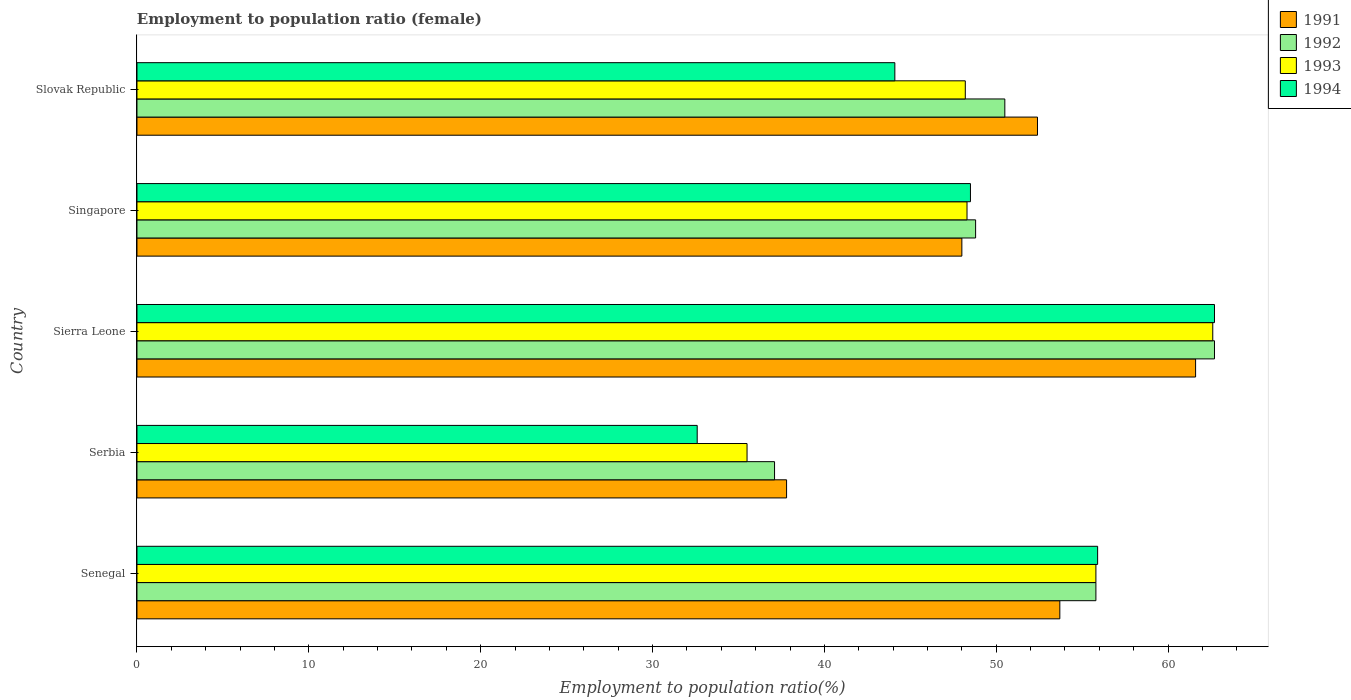How many different coloured bars are there?
Offer a terse response. 4. How many groups of bars are there?
Offer a very short reply. 5. Are the number of bars per tick equal to the number of legend labels?
Provide a succinct answer. Yes. How many bars are there on the 3rd tick from the top?
Give a very brief answer. 4. What is the label of the 1st group of bars from the top?
Keep it short and to the point. Slovak Republic. What is the employment to population ratio in 1993 in Senegal?
Ensure brevity in your answer.  55.8. Across all countries, what is the maximum employment to population ratio in 1994?
Your answer should be compact. 62.7. Across all countries, what is the minimum employment to population ratio in 1994?
Provide a succinct answer. 32.6. In which country was the employment to population ratio in 1994 maximum?
Offer a very short reply. Sierra Leone. In which country was the employment to population ratio in 1991 minimum?
Provide a short and direct response. Serbia. What is the total employment to population ratio in 1991 in the graph?
Offer a terse response. 253.5. What is the difference between the employment to population ratio in 1991 in Serbia and that in Slovak Republic?
Provide a succinct answer. -14.6. What is the difference between the employment to population ratio in 1993 in Serbia and the employment to population ratio in 1991 in Singapore?
Give a very brief answer. -12.5. What is the average employment to population ratio in 1991 per country?
Your answer should be very brief. 50.7. What is the difference between the employment to population ratio in 1994 and employment to population ratio in 1991 in Serbia?
Provide a succinct answer. -5.2. In how many countries, is the employment to population ratio in 1992 greater than 60 %?
Offer a very short reply. 1. What is the ratio of the employment to population ratio in 1993 in Senegal to that in Serbia?
Give a very brief answer. 1.57. Is the difference between the employment to population ratio in 1994 in Senegal and Slovak Republic greater than the difference between the employment to population ratio in 1991 in Senegal and Slovak Republic?
Your answer should be compact. Yes. What is the difference between the highest and the second highest employment to population ratio in 1991?
Give a very brief answer. 7.9. What is the difference between the highest and the lowest employment to population ratio in 1993?
Your answer should be very brief. 27.1. What does the 4th bar from the bottom in Senegal represents?
Your answer should be compact. 1994. Is it the case that in every country, the sum of the employment to population ratio in 1993 and employment to population ratio in 1992 is greater than the employment to population ratio in 1994?
Offer a terse response. Yes. How many bars are there?
Your answer should be compact. 20. What is the difference between two consecutive major ticks on the X-axis?
Give a very brief answer. 10. How many legend labels are there?
Ensure brevity in your answer.  4. How are the legend labels stacked?
Keep it short and to the point. Vertical. What is the title of the graph?
Give a very brief answer. Employment to population ratio (female). What is the Employment to population ratio(%) in 1991 in Senegal?
Provide a succinct answer. 53.7. What is the Employment to population ratio(%) of 1992 in Senegal?
Give a very brief answer. 55.8. What is the Employment to population ratio(%) in 1993 in Senegal?
Make the answer very short. 55.8. What is the Employment to population ratio(%) of 1994 in Senegal?
Offer a terse response. 55.9. What is the Employment to population ratio(%) of 1991 in Serbia?
Offer a terse response. 37.8. What is the Employment to population ratio(%) of 1992 in Serbia?
Provide a succinct answer. 37.1. What is the Employment to population ratio(%) in 1993 in Serbia?
Ensure brevity in your answer.  35.5. What is the Employment to population ratio(%) of 1994 in Serbia?
Your answer should be very brief. 32.6. What is the Employment to population ratio(%) in 1991 in Sierra Leone?
Provide a succinct answer. 61.6. What is the Employment to population ratio(%) in 1992 in Sierra Leone?
Provide a succinct answer. 62.7. What is the Employment to population ratio(%) in 1993 in Sierra Leone?
Provide a short and direct response. 62.6. What is the Employment to population ratio(%) of 1994 in Sierra Leone?
Your response must be concise. 62.7. What is the Employment to population ratio(%) of 1992 in Singapore?
Offer a terse response. 48.8. What is the Employment to population ratio(%) of 1993 in Singapore?
Your response must be concise. 48.3. What is the Employment to population ratio(%) of 1994 in Singapore?
Make the answer very short. 48.5. What is the Employment to population ratio(%) in 1991 in Slovak Republic?
Keep it short and to the point. 52.4. What is the Employment to population ratio(%) of 1992 in Slovak Republic?
Keep it short and to the point. 50.5. What is the Employment to population ratio(%) of 1993 in Slovak Republic?
Your answer should be compact. 48.2. What is the Employment to population ratio(%) in 1994 in Slovak Republic?
Give a very brief answer. 44.1. Across all countries, what is the maximum Employment to population ratio(%) in 1991?
Your answer should be compact. 61.6. Across all countries, what is the maximum Employment to population ratio(%) of 1992?
Offer a terse response. 62.7. Across all countries, what is the maximum Employment to population ratio(%) in 1993?
Give a very brief answer. 62.6. Across all countries, what is the maximum Employment to population ratio(%) in 1994?
Make the answer very short. 62.7. Across all countries, what is the minimum Employment to population ratio(%) of 1991?
Keep it short and to the point. 37.8. Across all countries, what is the minimum Employment to population ratio(%) in 1992?
Offer a terse response. 37.1. Across all countries, what is the minimum Employment to population ratio(%) of 1993?
Your response must be concise. 35.5. Across all countries, what is the minimum Employment to population ratio(%) of 1994?
Your response must be concise. 32.6. What is the total Employment to population ratio(%) of 1991 in the graph?
Ensure brevity in your answer.  253.5. What is the total Employment to population ratio(%) of 1992 in the graph?
Your response must be concise. 254.9. What is the total Employment to population ratio(%) of 1993 in the graph?
Give a very brief answer. 250.4. What is the total Employment to population ratio(%) of 1994 in the graph?
Offer a terse response. 243.8. What is the difference between the Employment to population ratio(%) in 1991 in Senegal and that in Serbia?
Provide a succinct answer. 15.9. What is the difference between the Employment to population ratio(%) in 1992 in Senegal and that in Serbia?
Make the answer very short. 18.7. What is the difference between the Employment to population ratio(%) in 1993 in Senegal and that in Serbia?
Make the answer very short. 20.3. What is the difference between the Employment to population ratio(%) in 1994 in Senegal and that in Serbia?
Provide a succinct answer. 23.3. What is the difference between the Employment to population ratio(%) of 1991 in Senegal and that in Sierra Leone?
Keep it short and to the point. -7.9. What is the difference between the Employment to population ratio(%) in 1992 in Senegal and that in Sierra Leone?
Make the answer very short. -6.9. What is the difference between the Employment to population ratio(%) in 1993 in Senegal and that in Sierra Leone?
Provide a succinct answer. -6.8. What is the difference between the Employment to population ratio(%) in 1992 in Senegal and that in Singapore?
Provide a succinct answer. 7. What is the difference between the Employment to population ratio(%) of 1991 in Senegal and that in Slovak Republic?
Offer a very short reply. 1.3. What is the difference between the Employment to population ratio(%) in 1992 in Senegal and that in Slovak Republic?
Offer a very short reply. 5.3. What is the difference between the Employment to population ratio(%) of 1991 in Serbia and that in Sierra Leone?
Keep it short and to the point. -23.8. What is the difference between the Employment to population ratio(%) of 1992 in Serbia and that in Sierra Leone?
Keep it short and to the point. -25.6. What is the difference between the Employment to population ratio(%) in 1993 in Serbia and that in Sierra Leone?
Offer a terse response. -27.1. What is the difference between the Employment to population ratio(%) of 1994 in Serbia and that in Sierra Leone?
Offer a very short reply. -30.1. What is the difference between the Employment to population ratio(%) in 1994 in Serbia and that in Singapore?
Keep it short and to the point. -15.9. What is the difference between the Employment to population ratio(%) in 1991 in Serbia and that in Slovak Republic?
Your answer should be compact. -14.6. What is the difference between the Employment to population ratio(%) in 1992 in Serbia and that in Slovak Republic?
Your answer should be very brief. -13.4. What is the difference between the Employment to population ratio(%) of 1991 in Sierra Leone and that in Slovak Republic?
Give a very brief answer. 9.2. What is the difference between the Employment to population ratio(%) of 1993 in Sierra Leone and that in Slovak Republic?
Ensure brevity in your answer.  14.4. What is the difference between the Employment to population ratio(%) in 1991 in Singapore and that in Slovak Republic?
Ensure brevity in your answer.  -4.4. What is the difference between the Employment to population ratio(%) in 1992 in Singapore and that in Slovak Republic?
Ensure brevity in your answer.  -1.7. What is the difference between the Employment to population ratio(%) in 1994 in Singapore and that in Slovak Republic?
Provide a succinct answer. 4.4. What is the difference between the Employment to population ratio(%) in 1991 in Senegal and the Employment to population ratio(%) in 1992 in Serbia?
Give a very brief answer. 16.6. What is the difference between the Employment to population ratio(%) of 1991 in Senegal and the Employment to population ratio(%) of 1994 in Serbia?
Your answer should be very brief. 21.1. What is the difference between the Employment to population ratio(%) of 1992 in Senegal and the Employment to population ratio(%) of 1993 in Serbia?
Ensure brevity in your answer.  20.3. What is the difference between the Employment to population ratio(%) in 1992 in Senegal and the Employment to population ratio(%) in 1994 in Serbia?
Keep it short and to the point. 23.2. What is the difference between the Employment to population ratio(%) of 1993 in Senegal and the Employment to population ratio(%) of 1994 in Serbia?
Provide a succinct answer. 23.2. What is the difference between the Employment to population ratio(%) of 1991 in Senegal and the Employment to population ratio(%) of 1992 in Sierra Leone?
Your response must be concise. -9. What is the difference between the Employment to population ratio(%) in 1991 in Senegal and the Employment to population ratio(%) in 1993 in Sierra Leone?
Make the answer very short. -8.9. What is the difference between the Employment to population ratio(%) of 1991 in Senegal and the Employment to population ratio(%) of 1994 in Sierra Leone?
Ensure brevity in your answer.  -9. What is the difference between the Employment to population ratio(%) of 1991 in Senegal and the Employment to population ratio(%) of 1993 in Singapore?
Your response must be concise. 5.4. What is the difference between the Employment to population ratio(%) in 1991 in Senegal and the Employment to population ratio(%) in 1994 in Singapore?
Keep it short and to the point. 5.2. What is the difference between the Employment to population ratio(%) in 1992 in Senegal and the Employment to population ratio(%) in 1993 in Singapore?
Offer a very short reply. 7.5. What is the difference between the Employment to population ratio(%) in 1993 in Senegal and the Employment to population ratio(%) in 1994 in Singapore?
Provide a succinct answer. 7.3. What is the difference between the Employment to population ratio(%) in 1991 in Senegal and the Employment to population ratio(%) in 1992 in Slovak Republic?
Keep it short and to the point. 3.2. What is the difference between the Employment to population ratio(%) of 1991 in Senegal and the Employment to population ratio(%) of 1994 in Slovak Republic?
Give a very brief answer. 9.6. What is the difference between the Employment to population ratio(%) of 1991 in Serbia and the Employment to population ratio(%) of 1992 in Sierra Leone?
Your response must be concise. -24.9. What is the difference between the Employment to population ratio(%) of 1991 in Serbia and the Employment to population ratio(%) of 1993 in Sierra Leone?
Provide a short and direct response. -24.8. What is the difference between the Employment to population ratio(%) of 1991 in Serbia and the Employment to population ratio(%) of 1994 in Sierra Leone?
Provide a short and direct response. -24.9. What is the difference between the Employment to population ratio(%) of 1992 in Serbia and the Employment to population ratio(%) of 1993 in Sierra Leone?
Offer a terse response. -25.5. What is the difference between the Employment to population ratio(%) in 1992 in Serbia and the Employment to population ratio(%) in 1994 in Sierra Leone?
Your response must be concise. -25.6. What is the difference between the Employment to population ratio(%) of 1993 in Serbia and the Employment to population ratio(%) of 1994 in Sierra Leone?
Your answer should be very brief. -27.2. What is the difference between the Employment to population ratio(%) in 1991 in Serbia and the Employment to population ratio(%) in 1993 in Singapore?
Your answer should be very brief. -10.5. What is the difference between the Employment to population ratio(%) in 1991 in Serbia and the Employment to population ratio(%) in 1994 in Singapore?
Your answer should be very brief. -10.7. What is the difference between the Employment to population ratio(%) of 1992 in Serbia and the Employment to population ratio(%) of 1993 in Singapore?
Give a very brief answer. -11.2. What is the difference between the Employment to population ratio(%) in 1991 in Serbia and the Employment to population ratio(%) in 1992 in Slovak Republic?
Offer a very short reply. -12.7. What is the difference between the Employment to population ratio(%) of 1992 in Serbia and the Employment to population ratio(%) of 1993 in Slovak Republic?
Offer a terse response. -11.1. What is the difference between the Employment to population ratio(%) of 1992 in Serbia and the Employment to population ratio(%) of 1994 in Slovak Republic?
Provide a succinct answer. -7. What is the difference between the Employment to population ratio(%) of 1991 in Sierra Leone and the Employment to population ratio(%) of 1993 in Singapore?
Keep it short and to the point. 13.3. What is the difference between the Employment to population ratio(%) in 1991 in Sierra Leone and the Employment to population ratio(%) in 1993 in Slovak Republic?
Your response must be concise. 13.4. What is the difference between the Employment to population ratio(%) in 1991 in Sierra Leone and the Employment to population ratio(%) in 1994 in Slovak Republic?
Provide a short and direct response. 17.5. What is the difference between the Employment to population ratio(%) in 1992 in Sierra Leone and the Employment to population ratio(%) in 1993 in Slovak Republic?
Offer a very short reply. 14.5. What is the difference between the Employment to population ratio(%) in 1991 in Singapore and the Employment to population ratio(%) in 1992 in Slovak Republic?
Make the answer very short. -2.5. What is the difference between the Employment to population ratio(%) of 1992 in Singapore and the Employment to population ratio(%) of 1993 in Slovak Republic?
Your response must be concise. 0.6. What is the average Employment to population ratio(%) in 1991 per country?
Ensure brevity in your answer.  50.7. What is the average Employment to population ratio(%) of 1992 per country?
Ensure brevity in your answer.  50.98. What is the average Employment to population ratio(%) in 1993 per country?
Your response must be concise. 50.08. What is the average Employment to population ratio(%) of 1994 per country?
Ensure brevity in your answer.  48.76. What is the difference between the Employment to population ratio(%) in 1991 and Employment to population ratio(%) in 1992 in Senegal?
Provide a short and direct response. -2.1. What is the difference between the Employment to population ratio(%) in 1991 and Employment to population ratio(%) in 1993 in Senegal?
Offer a very short reply. -2.1. What is the difference between the Employment to population ratio(%) in 1992 and Employment to population ratio(%) in 1994 in Senegal?
Give a very brief answer. -0.1. What is the difference between the Employment to population ratio(%) of 1991 and Employment to population ratio(%) of 1992 in Serbia?
Offer a terse response. 0.7. What is the difference between the Employment to population ratio(%) in 1991 and Employment to population ratio(%) in 1993 in Serbia?
Keep it short and to the point. 2.3. What is the difference between the Employment to population ratio(%) of 1991 and Employment to population ratio(%) of 1994 in Serbia?
Your answer should be very brief. 5.2. What is the difference between the Employment to population ratio(%) of 1992 and Employment to population ratio(%) of 1993 in Serbia?
Keep it short and to the point. 1.6. What is the difference between the Employment to population ratio(%) of 1992 and Employment to population ratio(%) of 1994 in Serbia?
Provide a succinct answer. 4.5. What is the difference between the Employment to population ratio(%) in 1991 and Employment to population ratio(%) in 1992 in Sierra Leone?
Offer a very short reply. -1.1. What is the difference between the Employment to population ratio(%) of 1992 and Employment to population ratio(%) of 1993 in Sierra Leone?
Make the answer very short. 0.1. What is the difference between the Employment to population ratio(%) of 1991 and Employment to population ratio(%) of 1992 in Singapore?
Offer a terse response. -0.8. What is the difference between the Employment to population ratio(%) of 1992 and Employment to population ratio(%) of 1993 in Singapore?
Provide a succinct answer. 0.5. What is the difference between the Employment to population ratio(%) of 1993 and Employment to population ratio(%) of 1994 in Singapore?
Give a very brief answer. -0.2. What is the difference between the Employment to population ratio(%) of 1991 and Employment to population ratio(%) of 1993 in Slovak Republic?
Give a very brief answer. 4.2. What is the difference between the Employment to population ratio(%) in 1991 and Employment to population ratio(%) in 1994 in Slovak Republic?
Make the answer very short. 8.3. What is the difference between the Employment to population ratio(%) of 1992 and Employment to population ratio(%) of 1994 in Slovak Republic?
Ensure brevity in your answer.  6.4. What is the difference between the Employment to population ratio(%) of 1993 and Employment to population ratio(%) of 1994 in Slovak Republic?
Provide a succinct answer. 4.1. What is the ratio of the Employment to population ratio(%) of 1991 in Senegal to that in Serbia?
Your response must be concise. 1.42. What is the ratio of the Employment to population ratio(%) of 1992 in Senegal to that in Serbia?
Ensure brevity in your answer.  1.5. What is the ratio of the Employment to population ratio(%) in 1993 in Senegal to that in Serbia?
Provide a short and direct response. 1.57. What is the ratio of the Employment to population ratio(%) in 1994 in Senegal to that in Serbia?
Provide a short and direct response. 1.71. What is the ratio of the Employment to population ratio(%) in 1991 in Senegal to that in Sierra Leone?
Make the answer very short. 0.87. What is the ratio of the Employment to population ratio(%) of 1992 in Senegal to that in Sierra Leone?
Your answer should be compact. 0.89. What is the ratio of the Employment to population ratio(%) in 1993 in Senegal to that in Sierra Leone?
Keep it short and to the point. 0.89. What is the ratio of the Employment to population ratio(%) of 1994 in Senegal to that in Sierra Leone?
Provide a short and direct response. 0.89. What is the ratio of the Employment to population ratio(%) in 1991 in Senegal to that in Singapore?
Ensure brevity in your answer.  1.12. What is the ratio of the Employment to population ratio(%) of 1992 in Senegal to that in Singapore?
Make the answer very short. 1.14. What is the ratio of the Employment to population ratio(%) of 1993 in Senegal to that in Singapore?
Offer a very short reply. 1.16. What is the ratio of the Employment to population ratio(%) in 1994 in Senegal to that in Singapore?
Provide a succinct answer. 1.15. What is the ratio of the Employment to population ratio(%) of 1991 in Senegal to that in Slovak Republic?
Your answer should be very brief. 1.02. What is the ratio of the Employment to population ratio(%) in 1992 in Senegal to that in Slovak Republic?
Keep it short and to the point. 1.1. What is the ratio of the Employment to population ratio(%) in 1993 in Senegal to that in Slovak Republic?
Make the answer very short. 1.16. What is the ratio of the Employment to population ratio(%) in 1994 in Senegal to that in Slovak Republic?
Offer a terse response. 1.27. What is the ratio of the Employment to population ratio(%) in 1991 in Serbia to that in Sierra Leone?
Offer a very short reply. 0.61. What is the ratio of the Employment to population ratio(%) of 1992 in Serbia to that in Sierra Leone?
Give a very brief answer. 0.59. What is the ratio of the Employment to population ratio(%) of 1993 in Serbia to that in Sierra Leone?
Offer a very short reply. 0.57. What is the ratio of the Employment to population ratio(%) in 1994 in Serbia to that in Sierra Leone?
Your response must be concise. 0.52. What is the ratio of the Employment to population ratio(%) of 1991 in Serbia to that in Singapore?
Provide a short and direct response. 0.79. What is the ratio of the Employment to population ratio(%) of 1992 in Serbia to that in Singapore?
Make the answer very short. 0.76. What is the ratio of the Employment to population ratio(%) of 1993 in Serbia to that in Singapore?
Keep it short and to the point. 0.73. What is the ratio of the Employment to population ratio(%) in 1994 in Serbia to that in Singapore?
Keep it short and to the point. 0.67. What is the ratio of the Employment to population ratio(%) of 1991 in Serbia to that in Slovak Republic?
Keep it short and to the point. 0.72. What is the ratio of the Employment to population ratio(%) in 1992 in Serbia to that in Slovak Republic?
Keep it short and to the point. 0.73. What is the ratio of the Employment to population ratio(%) in 1993 in Serbia to that in Slovak Republic?
Keep it short and to the point. 0.74. What is the ratio of the Employment to population ratio(%) of 1994 in Serbia to that in Slovak Republic?
Offer a terse response. 0.74. What is the ratio of the Employment to population ratio(%) of 1991 in Sierra Leone to that in Singapore?
Your answer should be compact. 1.28. What is the ratio of the Employment to population ratio(%) in 1992 in Sierra Leone to that in Singapore?
Provide a succinct answer. 1.28. What is the ratio of the Employment to population ratio(%) of 1993 in Sierra Leone to that in Singapore?
Your response must be concise. 1.3. What is the ratio of the Employment to population ratio(%) of 1994 in Sierra Leone to that in Singapore?
Ensure brevity in your answer.  1.29. What is the ratio of the Employment to population ratio(%) in 1991 in Sierra Leone to that in Slovak Republic?
Give a very brief answer. 1.18. What is the ratio of the Employment to population ratio(%) in 1992 in Sierra Leone to that in Slovak Republic?
Give a very brief answer. 1.24. What is the ratio of the Employment to population ratio(%) of 1993 in Sierra Leone to that in Slovak Republic?
Your answer should be compact. 1.3. What is the ratio of the Employment to population ratio(%) in 1994 in Sierra Leone to that in Slovak Republic?
Your response must be concise. 1.42. What is the ratio of the Employment to population ratio(%) in 1991 in Singapore to that in Slovak Republic?
Keep it short and to the point. 0.92. What is the ratio of the Employment to population ratio(%) of 1992 in Singapore to that in Slovak Republic?
Offer a very short reply. 0.97. What is the ratio of the Employment to population ratio(%) in 1993 in Singapore to that in Slovak Republic?
Offer a very short reply. 1. What is the ratio of the Employment to population ratio(%) in 1994 in Singapore to that in Slovak Republic?
Provide a short and direct response. 1.1. What is the difference between the highest and the second highest Employment to population ratio(%) in 1991?
Offer a terse response. 7.9. What is the difference between the highest and the second highest Employment to population ratio(%) of 1992?
Give a very brief answer. 6.9. What is the difference between the highest and the second highest Employment to population ratio(%) in 1993?
Ensure brevity in your answer.  6.8. What is the difference between the highest and the lowest Employment to population ratio(%) of 1991?
Make the answer very short. 23.8. What is the difference between the highest and the lowest Employment to population ratio(%) in 1992?
Keep it short and to the point. 25.6. What is the difference between the highest and the lowest Employment to population ratio(%) of 1993?
Ensure brevity in your answer.  27.1. What is the difference between the highest and the lowest Employment to population ratio(%) of 1994?
Offer a terse response. 30.1. 